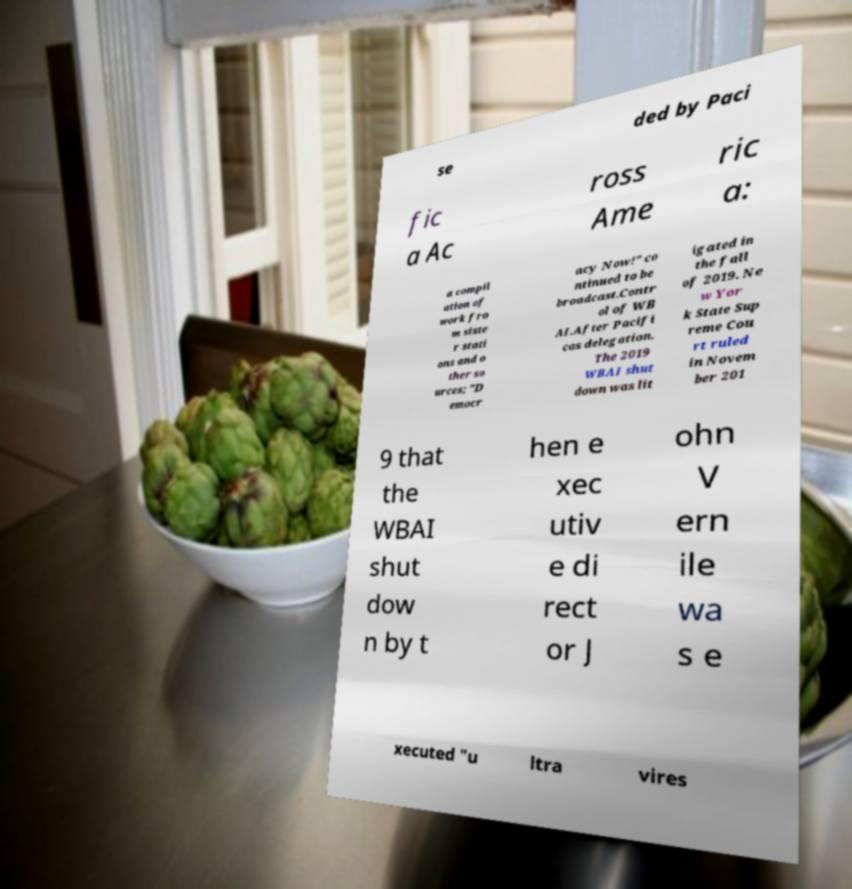I need the written content from this picture converted into text. Can you do that? se ded by Paci fic a Ac ross Ame ric a: a compil ation of work fro m siste r stati ons and o ther so urces; "D emocr acy Now!" co ntinued to be broadcast.Contr ol of WB AI.After Pacifi cas delegation. The 2019 WBAI shut down was lit igated in the fall of 2019. Ne w Yor k State Sup reme Cou rt ruled in Novem ber 201 9 that the WBAI shut dow n by t hen e xec utiv e di rect or J ohn V ern ile wa s e xecuted "u ltra vires 